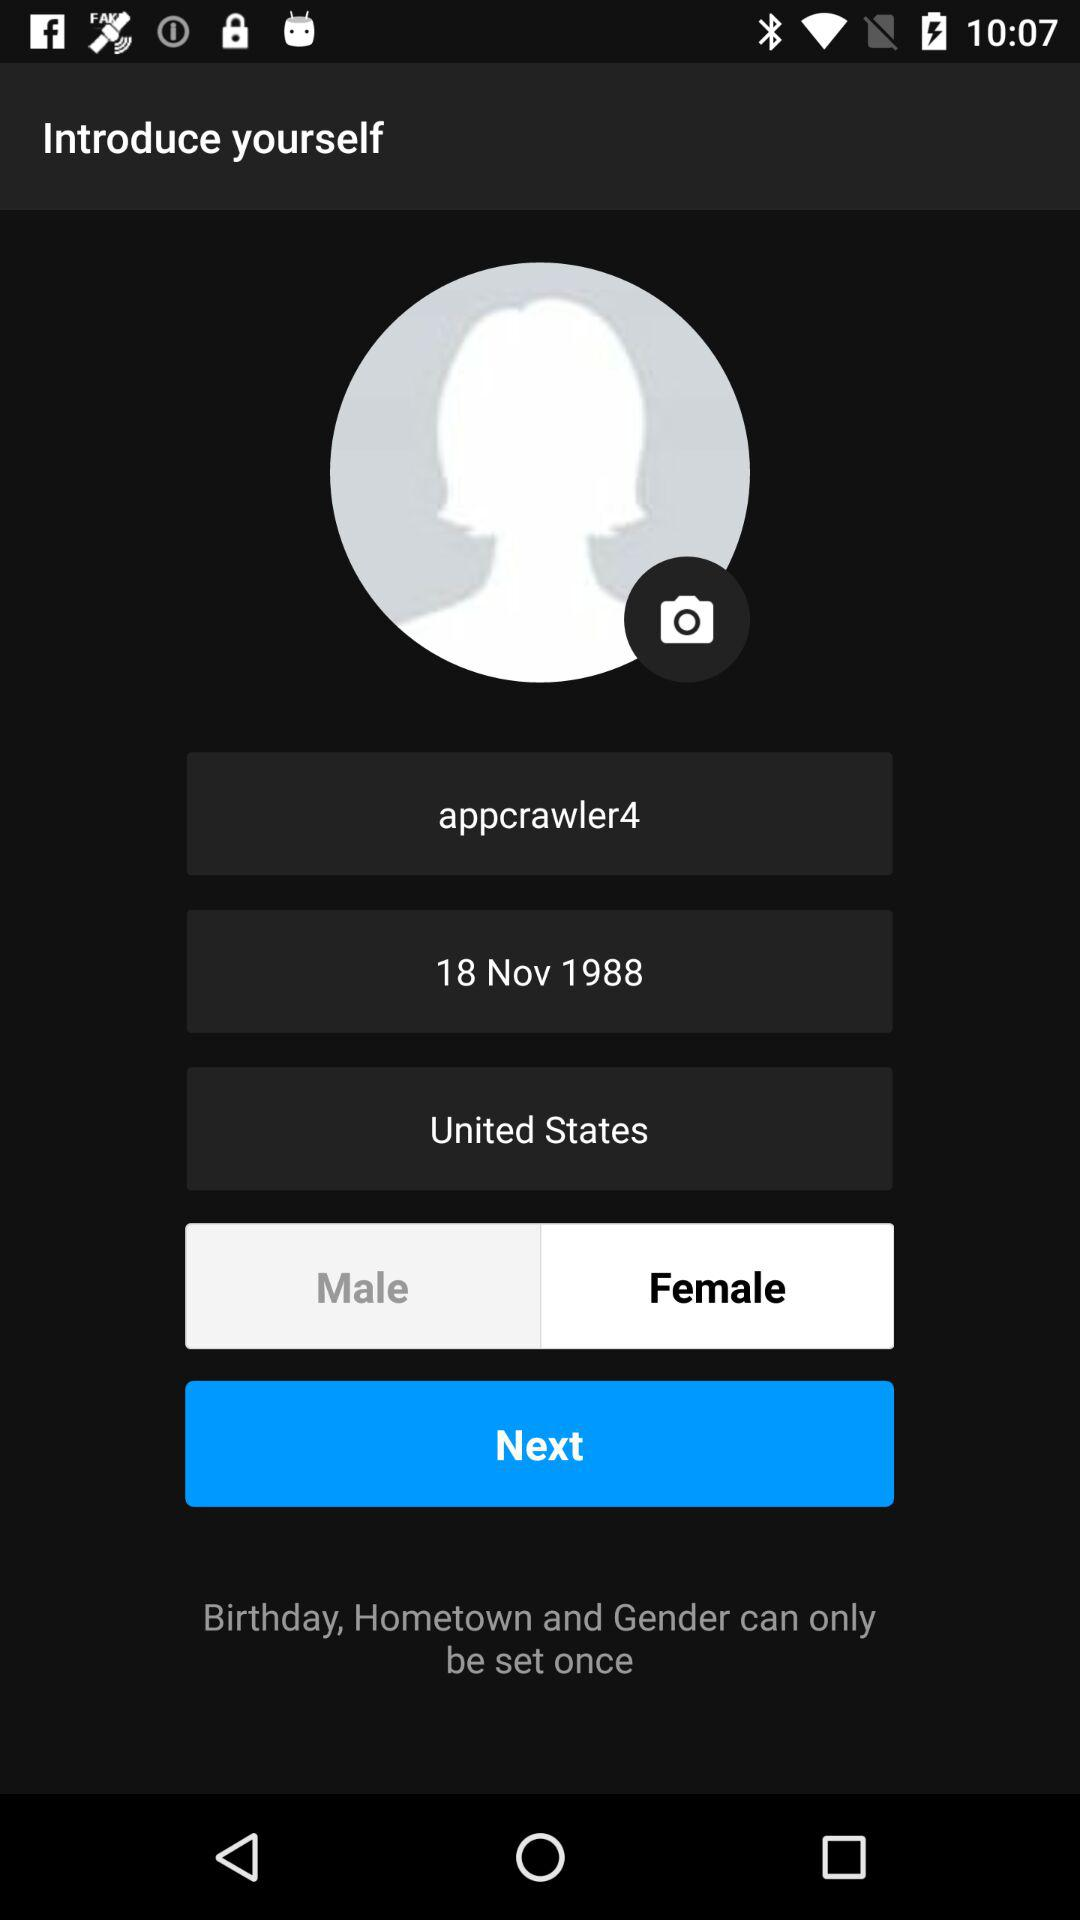Which country is mentioned? The mentioned country is the United States. 